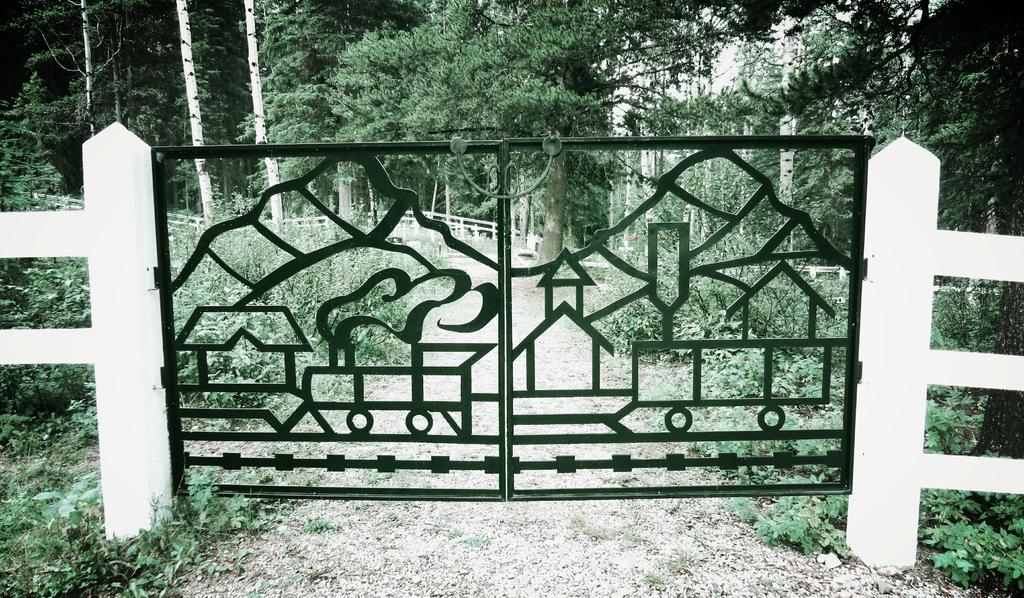What type of gate is visible in the image? There is an iron gate in the image. How is the iron gate connected to the surrounding structure? The iron gate is attached to a fence. What material is the fence made of? The fence appears to be made of wood. What type of vegetation can be seen in the image? There are plants, bushes, and trees with branches and leaves in the image. How many fish can be seen swimming in the fog in the image? There are no fish or fog present in the image; it features an iron gate, a wooden fence, and various types of vegetation. 